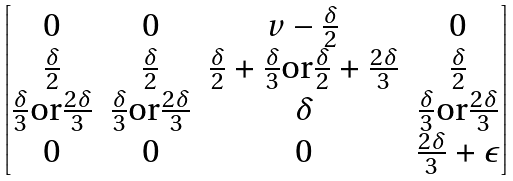<formula> <loc_0><loc_0><loc_500><loc_500>\begin{bmatrix} 0 & 0 & v - \frac { \delta } { 2 } & 0 \\ \frac { \delta } { 2 } & \frac { \delta } { 2 } & \frac { \delta } { 2 } + \frac { \delta } { 3 } \text {or} \frac { \delta } { 2 } + \frac { 2 \delta } { 3 } & \frac { \delta } { 2 } \\ \frac { \delta } { 3 } \text {or} \frac { 2 \delta } { 3 } & \frac { \delta } { 3 } \text {or} \frac { 2 \delta } { 3 } & \delta & \frac { \delta } { 3 } \text {or} \frac { 2 \delta } { 3 } \\ 0 & 0 & 0 & \frac { 2 \delta } { 3 } + \epsilon \end{bmatrix}</formula> 